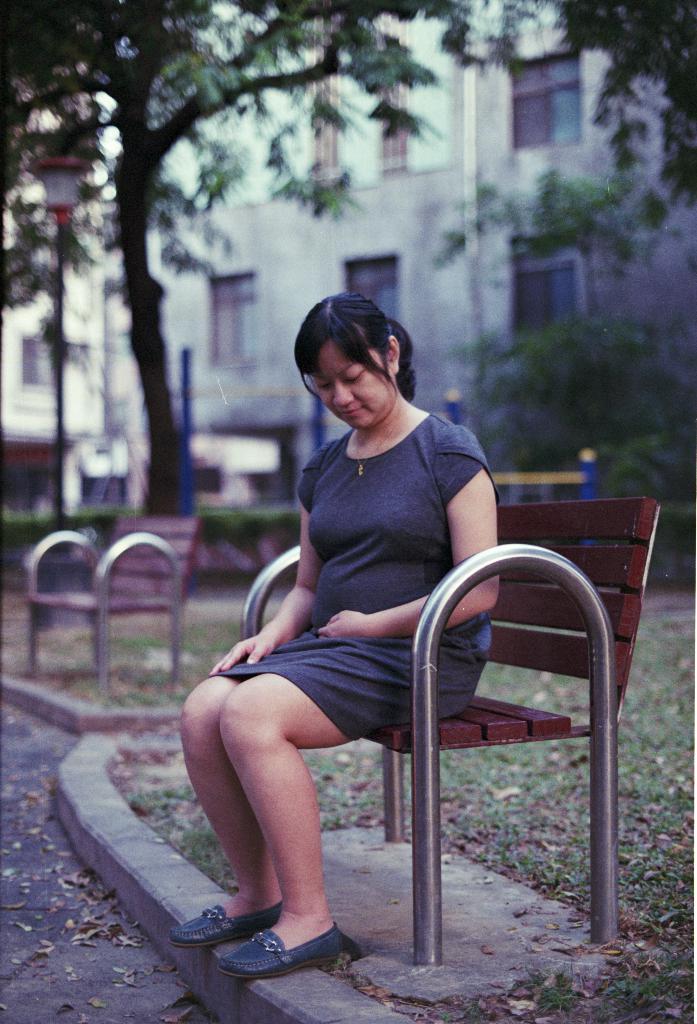How would you summarize this image in a sentence or two? There are benches. On the bench a lady is sitting. On the ground there is grass. In the back there are trees and building with windows. 